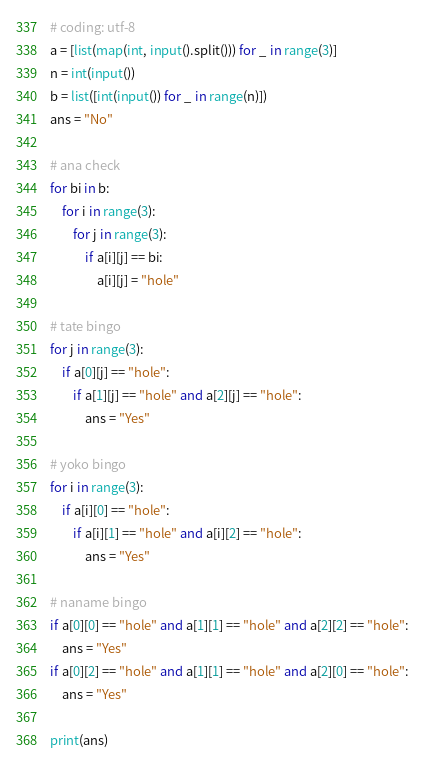<code> <loc_0><loc_0><loc_500><loc_500><_Python_># coding: utf-8
a = [list(map(int, input().split())) for _ in range(3)]
n = int(input())
b = list([int(input()) for _ in range(n)])
ans = "No"

# ana check
for bi in b:
    for i in range(3):
        for j in range(3):
            if a[i][j] == bi:
                a[i][j] = "hole"

# tate bingo
for j in range(3):
    if a[0][j] == "hole":
        if a[1][j] == "hole" and a[2][j] == "hole":
            ans = "Yes"

# yoko bingo
for i in range(3):
    if a[i][0] == "hole":
        if a[i][1] == "hole" and a[i][2] == "hole":
            ans = "Yes"

# naname bingo
if a[0][0] == "hole" and a[1][1] == "hole" and a[2][2] == "hole":
    ans = "Yes"
if a[0][2] == "hole" and a[1][1] == "hole" and a[2][0] == "hole":
    ans = "Yes"

print(ans)
</code> 